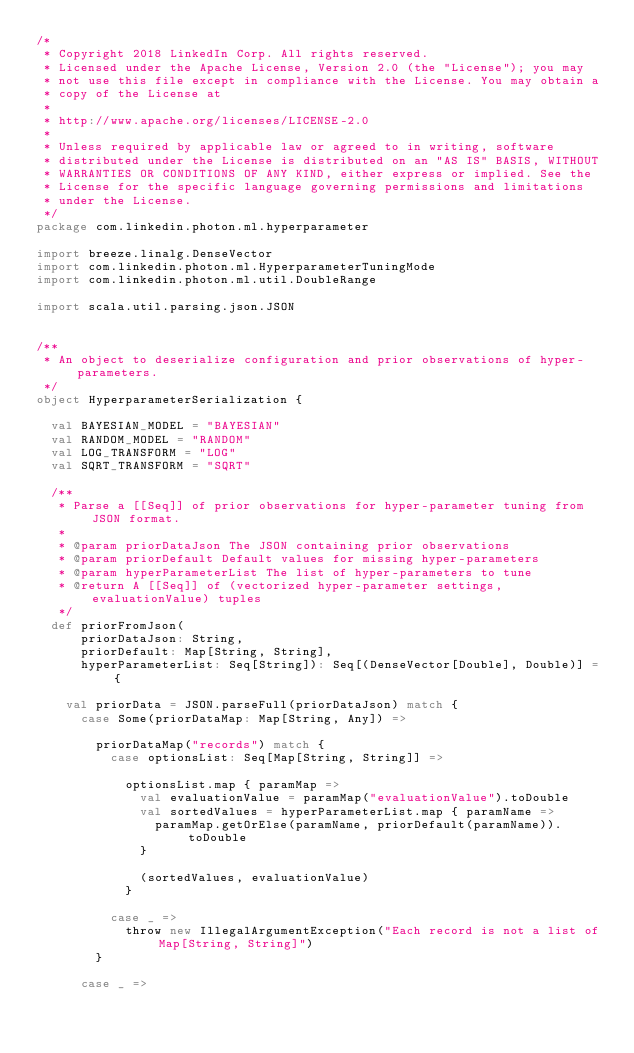Convert code to text. <code><loc_0><loc_0><loc_500><loc_500><_Scala_>/*
 * Copyright 2018 LinkedIn Corp. All rights reserved.
 * Licensed under the Apache License, Version 2.0 (the "License"); you may
 * not use this file except in compliance with the License. You may obtain a
 * copy of the License at
 *
 * http://www.apache.org/licenses/LICENSE-2.0
 *
 * Unless required by applicable law or agreed to in writing, software
 * distributed under the License is distributed on an "AS IS" BASIS, WITHOUT
 * WARRANTIES OR CONDITIONS OF ANY KIND, either express or implied. See the
 * License for the specific language governing permissions and limitations
 * under the License.
 */
package com.linkedin.photon.ml.hyperparameter

import breeze.linalg.DenseVector
import com.linkedin.photon.ml.HyperparameterTuningMode
import com.linkedin.photon.ml.util.DoubleRange

import scala.util.parsing.json.JSON


/**
 * An object to deserialize configuration and prior observations of hyper-parameters.
 */
object HyperparameterSerialization {

  val BAYESIAN_MODEL = "BAYESIAN"
  val RANDOM_MODEL = "RANDOM"
  val LOG_TRANSFORM = "LOG"
  val SQRT_TRANSFORM = "SQRT"

  /**
   * Parse a [[Seq]] of prior observations for hyper-parameter tuning from JSON format.
   *
   * @param priorDataJson The JSON containing prior observations
   * @param priorDefault Default values for missing hyper-parameters
   * @param hyperParameterList The list of hyper-parameters to tune
   * @return A [[Seq]] of (vectorized hyper-parameter settings, evaluationValue) tuples
   */
  def priorFromJson(
      priorDataJson: String,
      priorDefault: Map[String, String],
      hyperParameterList: Seq[String]): Seq[(DenseVector[Double], Double)] = {

    val priorData = JSON.parseFull(priorDataJson) match {
      case Some(priorDataMap: Map[String, Any]) =>

        priorDataMap("records") match {
          case optionsList: Seq[Map[String, String]] =>

            optionsList.map { paramMap =>
              val evaluationValue = paramMap("evaluationValue").toDouble
              val sortedValues = hyperParameterList.map { paramName =>
                paramMap.getOrElse(paramName, priorDefault(paramName)).toDouble
              }

              (sortedValues, evaluationValue)
            }

          case _ =>
            throw new IllegalArgumentException("Each record is not a list of Map[String, String]")
        }

      case _ =></code> 